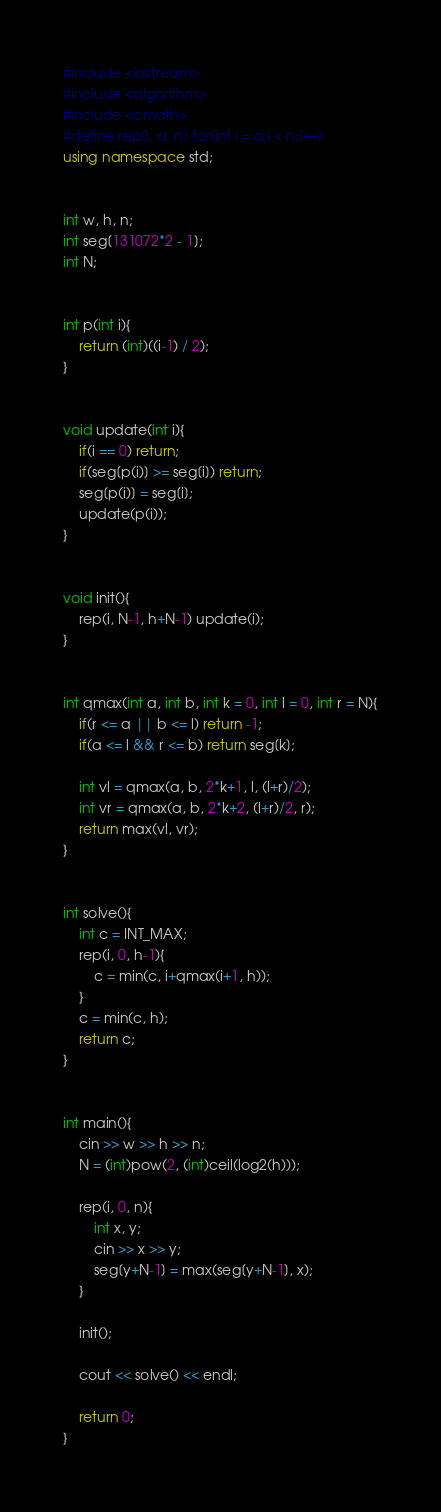Convert code to text. <code><loc_0><loc_0><loc_500><loc_500><_C++_>#include <iostream>
#include <algorithm>
#include <cmath>
#define rep(i, a, n) for(int i = a;i < n;i++)
using namespace std;


int w, h, n;
int seg[131072*2 - 1];
int N;


int p(int i){
	return (int)((i-1) / 2);
}


void update(int i){
	if(i == 0) return;
	if(seg[p(i)] >= seg[i]) return;
	seg[p(i)] = seg[i];
	update(p(i));
}


void init(){
	rep(i, N-1, h+N-1) update(i);
}


int qmax(int a, int b, int k = 0, int l = 0, int r = N){
	if(r <= a || b <= l) return -1;
	if(a <= l && r <= b) return seg[k];

	int vl = qmax(a, b, 2*k+1, l, (l+r)/2);
	int vr = qmax(a, b, 2*k+2, (l+r)/2, r);
	return max(vl, vr);
}


int solve(){
	int c = INT_MAX;
	rep(i, 0, h-1){
		c = min(c, i+qmax(i+1, h));
	}
	c = min(c, h);
	return c;
}


int main(){
	cin >> w >> h >> n;
	N = (int)pow(2, (int)ceil(log2(h)));
	
	rep(i, 0, n){
		int x, y;
		cin >> x >> y;
		seg[y+N-1] = max(seg[y+N-1], x);
	}
	
	init();
	
	cout << solve() << endl;
	
	return 0;
}
</code> 